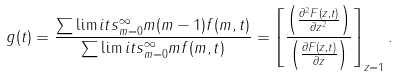Convert formula to latex. <formula><loc_0><loc_0><loc_500><loc_500>g ( t ) = \frac { \sum \lim i t s _ { m = 0 } ^ { \infty } m ( m - 1 ) f ( m , t ) } { \sum \lim i t s _ { m = 0 } ^ { \infty } m f ( m , t ) } = \left [ \frac { \left ( \frac { \partial ^ { 2 } F ( z , t ) } { \partial z ^ { 2 } } \right ) } { \left ( \frac { \partial F ( z , t ) } { \partial z } \right ) } \right ] _ { z = 1 } .</formula> 